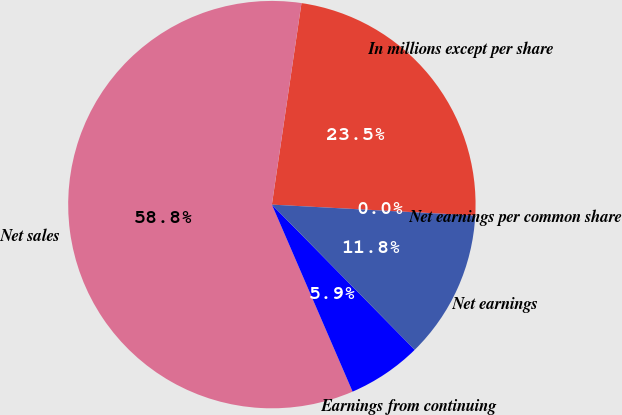Convert chart to OTSL. <chart><loc_0><loc_0><loc_500><loc_500><pie_chart><fcel>In millions except per share<fcel>Net sales<fcel>Earnings from continuing<fcel>Net earnings<fcel>Net earnings per common share<nl><fcel>23.53%<fcel>58.81%<fcel>5.89%<fcel>11.77%<fcel>0.01%<nl></chart> 